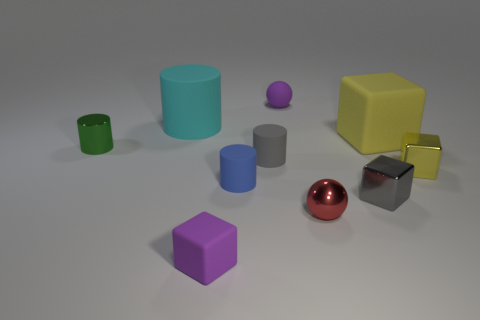What number of big objects are either things or shiny balls?
Provide a short and direct response. 2. Is the number of big yellow things that are to the left of the cyan cylinder the same as the number of tiny yellow cubes that are behind the big yellow cube?
Offer a very short reply. Yes. What number of other objects are the same color as the big matte cylinder?
Offer a terse response. 0. There is a big rubber block; is its color the same as the rubber cube left of the tiny red sphere?
Provide a succinct answer. No. What number of purple things are either rubber things or big matte cylinders?
Offer a terse response. 2. Are there the same number of tiny shiny cylinders on the left side of the small green cylinder and large objects?
Ensure brevity in your answer.  No. Are there any other things that have the same size as the purple sphere?
Give a very brief answer. Yes. What color is the other metallic object that is the same shape as the small yellow object?
Provide a succinct answer. Gray. What number of purple objects are the same shape as the small green metal object?
Your response must be concise. 0. There is a block that is the same color as the rubber sphere; what is its material?
Offer a very short reply. Rubber. 